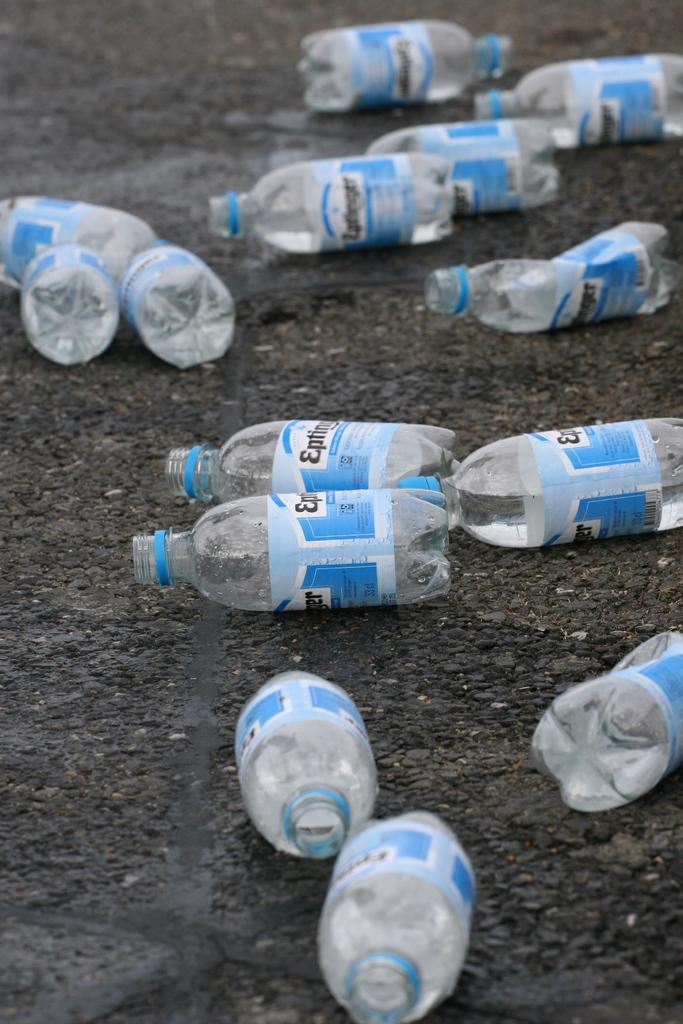Where was the image taken? The image was taken outdoors. What can be seen in the image besides the outdoor setting? There is a road in the image. What else is present on the road? There are empty bottles on the road. What type of knot is being tied by the person in the image? There is no person present in the image, and therefore no one is tying a knot. 